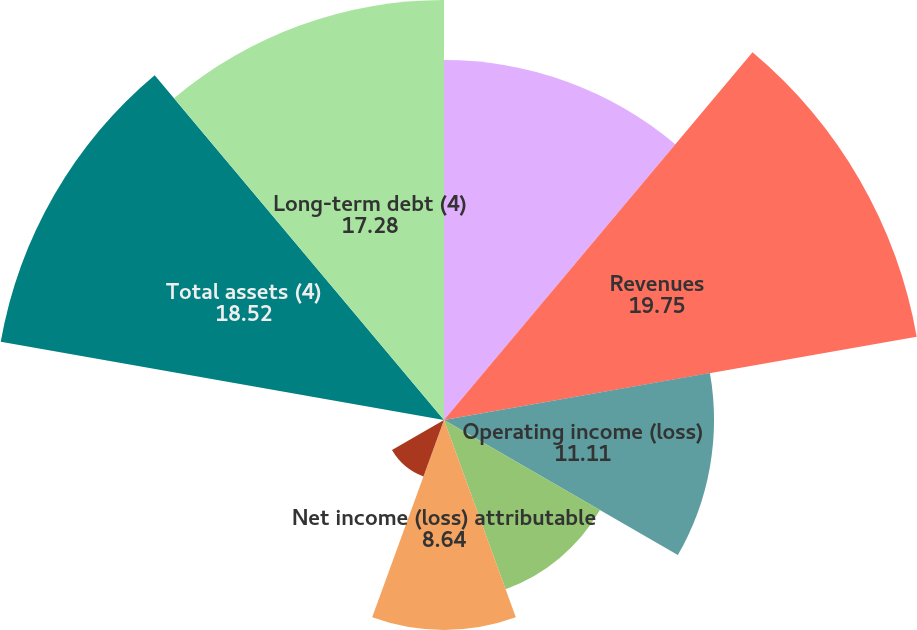Convert chart. <chart><loc_0><loc_0><loc_500><loc_500><pie_chart><fcel>( in millions except per share<fcel>Revenues<fcel>Operating income (loss)<fcel>Income (loss) from continuing<fcel>Net income (loss) attributable<fcel>Diluted earnings (losses) per<fcel>Cash dividends declared per<fcel>Total assets (4)<fcel>Long-term debt (4)<nl><fcel>14.81%<fcel>19.75%<fcel>11.11%<fcel>7.41%<fcel>8.64%<fcel>2.47%<fcel>0.0%<fcel>18.52%<fcel>17.28%<nl></chart> 